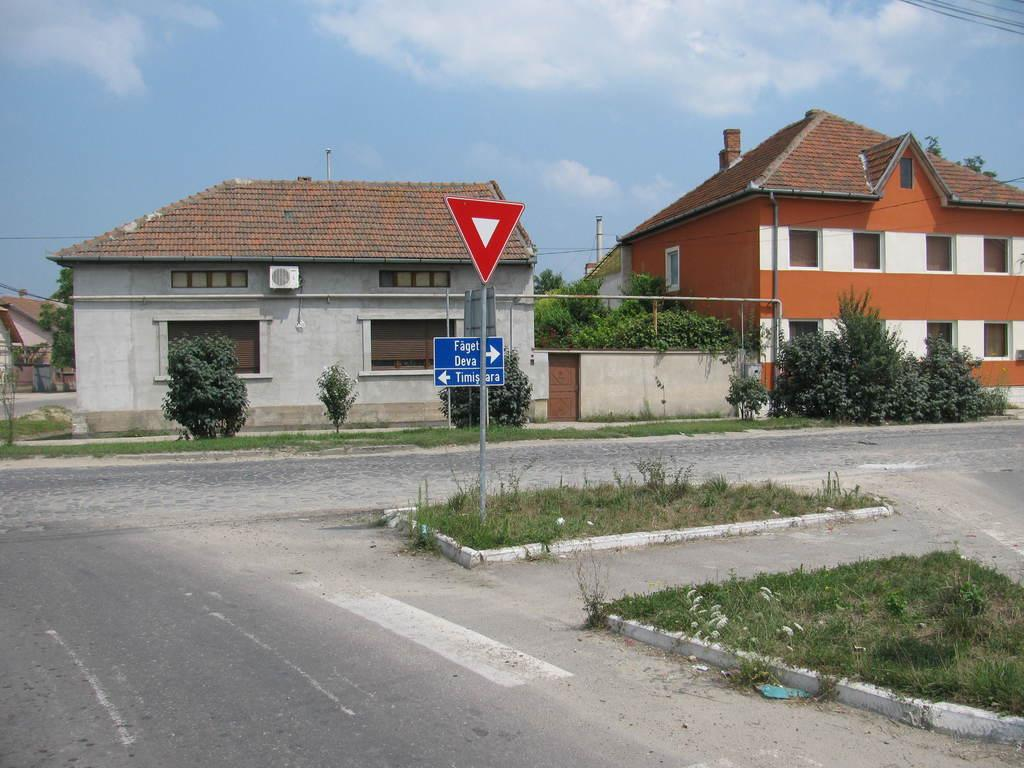What type of pathway can be seen in the image? There is a road in the image. What type of structures are present in the image? There are houses in the image. What type of vegetation is present in the image? Plants and trees are visible in the image. What type of objects are present in the image? Boards and an air conditioner are visible in the image. What else can be seen in the image? There are other objects in the image. What is visible in the background of the image? The sky is visible in the background of the image. What type of weather can be inferred from the image? Clouds are present in the sky, suggesting a partly cloudy day. Can you tell me what type of watch the woman is wearing in the image? There is no woman or watch present in the image. What type of kettle is visible in the image? There is no kettle present in the image. 